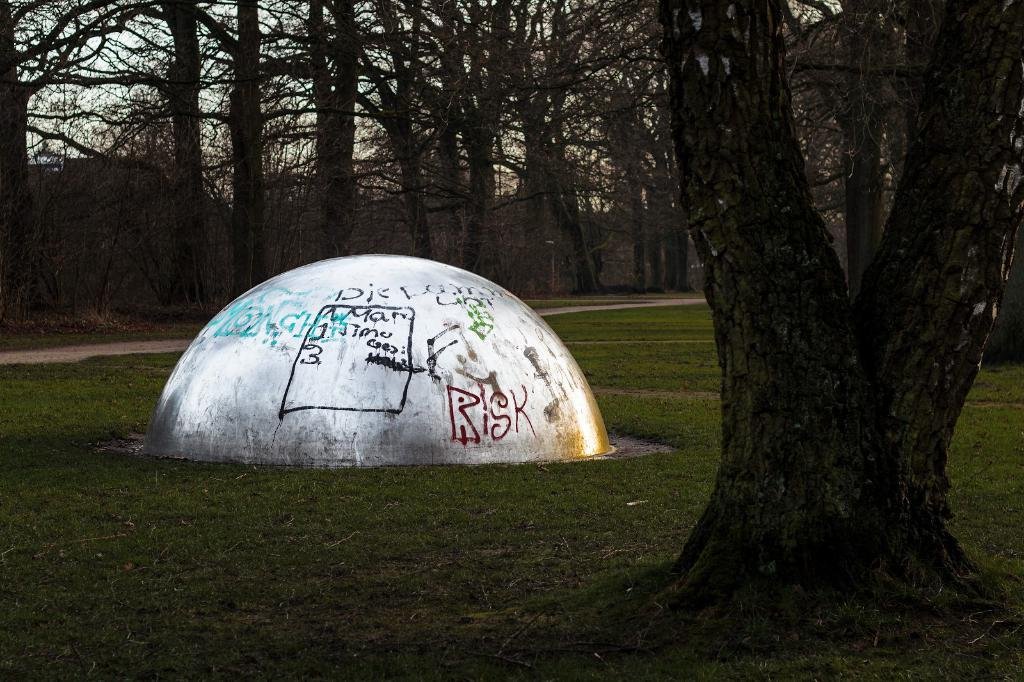What type of structure is present in the image? There is a stone wall in the image. What is written or depicted on the stone wall? There is text on the stone wall. What type of vegetation can be seen in the image? There is grass visible in the image. What can be seen in the background of the image? There are trees and the sky visible in the background of the image. What day of the week is it in the image? The day of the week is not mentioned or depicted in the image, so it cannot be determined. 